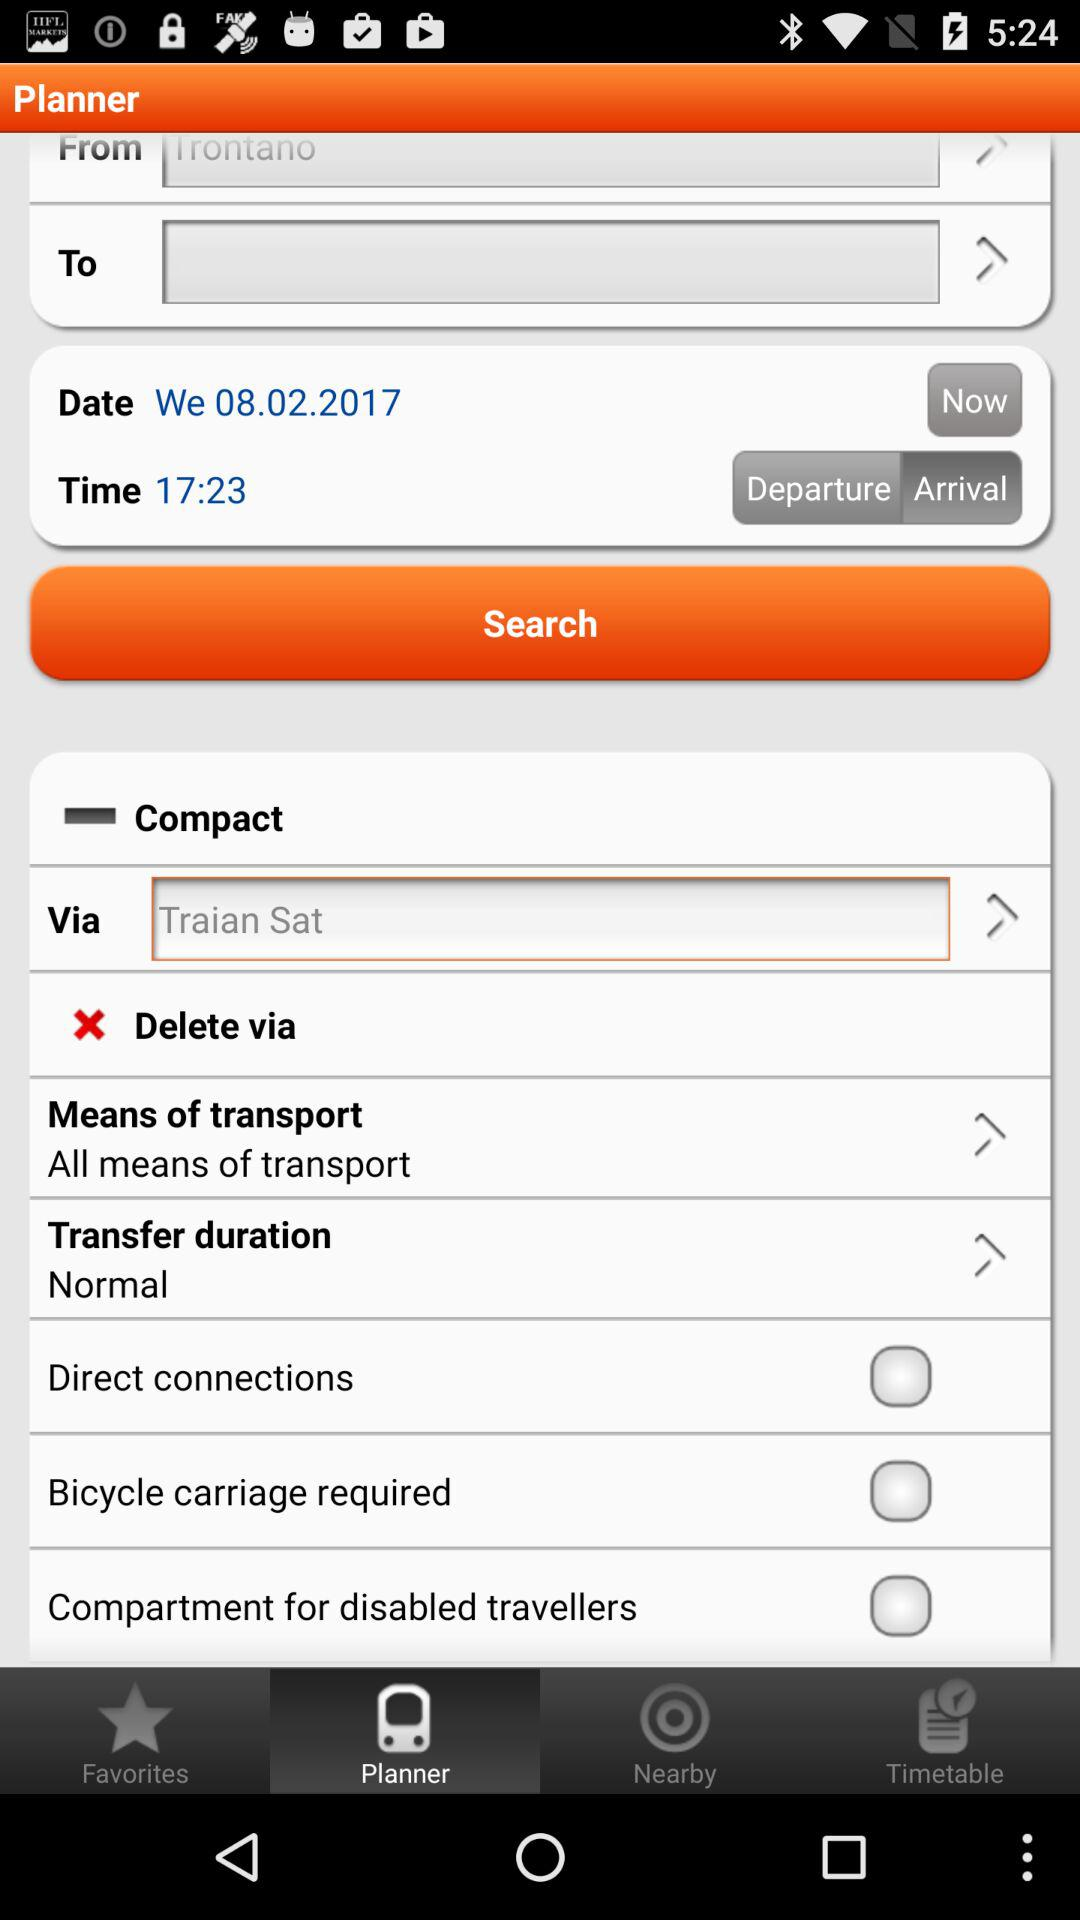Which tab is selected? The selected tab is "Planner". 